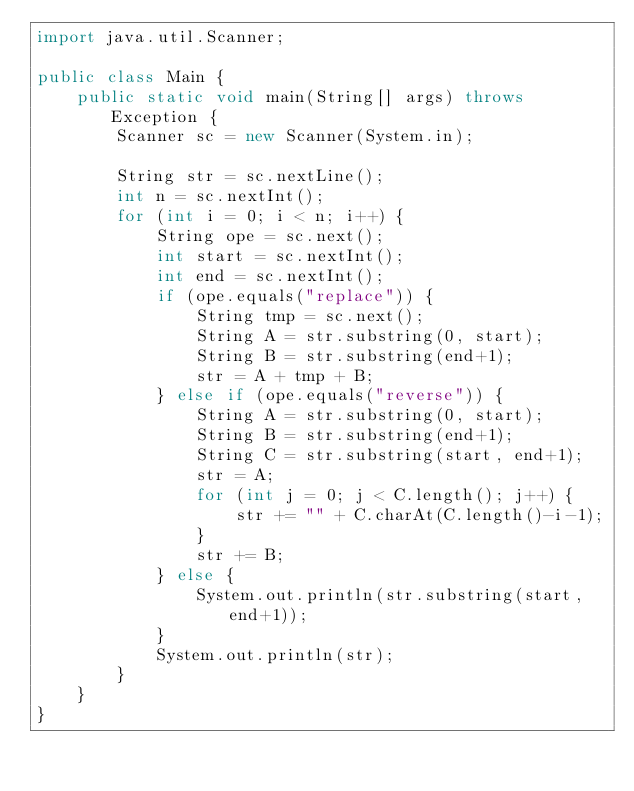<code> <loc_0><loc_0><loc_500><loc_500><_Java_>import java.util.Scanner;

public class Main {
	public static void main(String[] args) throws Exception {
		Scanner sc = new Scanner(System.in);
		
		String str = sc.nextLine();
		int n = sc.nextInt();
		for (int i = 0; i < n; i++) {
			String ope = sc.next();
			int start = sc.nextInt();
			int end = sc.nextInt();
			if (ope.equals("replace")) {
				String tmp = sc.next();
				String A = str.substring(0, start);
				String B = str.substring(end+1);
				str = A + tmp + B;
			} else if (ope.equals("reverse")) {
				String A = str.substring(0, start);
				String B = str.substring(end+1);
				String C = str.substring(start, end+1);
				str = A;
				for (int j = 0; j < C.length(); j++) {
					str += "" + C.charAt(C.length()-i-1);
				}
				str += B;
			} else {
				System.out.println(str.substring(start, end+1));
			}
			System.out.println(str);
		}
	}
}

</code> 